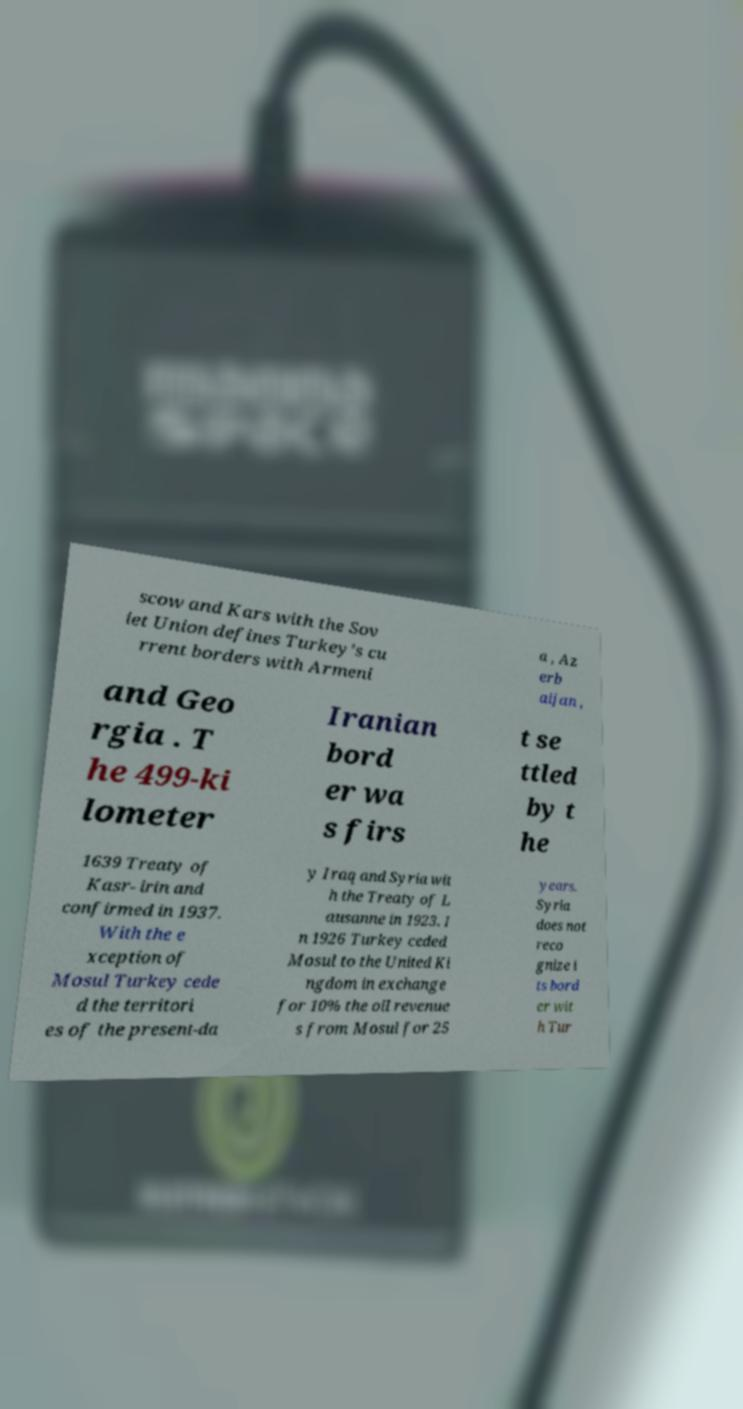What messages or text are displayed in this image? I need them in a readable, typed format. scow and Kars with the Sov iet Union defines Turkey’s cu rrent borders with Armeni a , Az erb aijan , and Geo rgia . T he 499-ki lometer Iranian bord er wa s firs t se ttled by t he 1639 Treaty of Kasr- irin and confirmed in 1937. With the e xception of Mosul Turkey cede d the territori es of the present-da y Iraq and Syria wit h the Treaty of L ausanne in 1923. I n 1926 Turkey ceded Mosul to the United Ki ngdom in exchange for 10% the oil revenue s from Mosul for 25 years. Syria does not reco gnize i ts bord er wit h Tur 